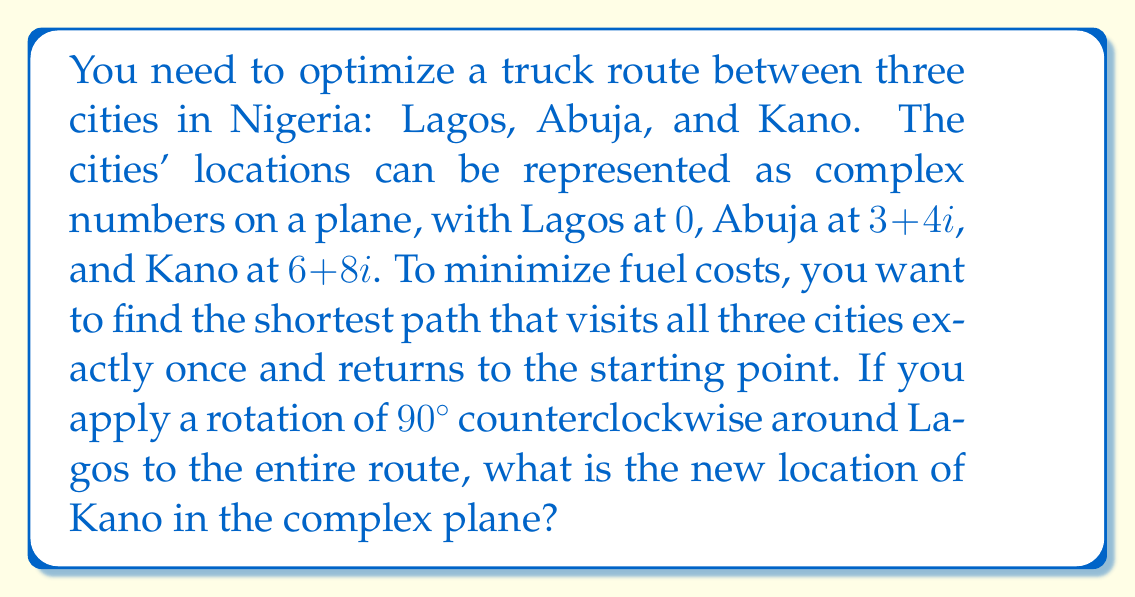Give your solution to this math problem. Let's approach this step-by-step:

1) First, we need to understand what a $90^\circ$ counterclockwise rotation means in terms of complex numbers. This rotation is equivalent to multiplying by $i$.

2) The original locations of the cities are:
   Lagos: $0$
   Abuja: $3+4i$
   Kano: $6+8i$

3) To rotate the entire route, we multiply each point by $i$:

   Lagos: $0 \cdot i = 0$
   Abuja: $(3+4i) \cdot i = 3i - 4 = -4 + 3i$
   Kano: $(6+8i) \cdot i = 6i - 8 = -8 + 6i$

4) Therefore, after the rotation, Kano's new location is $-8 + 6i$.

5) We can verify this geometrically:
   - The original point $(6,8)$ is at a distance of $\sqrt{6^2 + 8^2} = 10$ from the origin.
   - The new point $(-8,6)$ is also at a distance of $\sqrt{(-8)^2 + 6^2} = 10$ from the origin.
   - The angle has changed by exactly $90^\circ$.
Answer: $-8 + 6i$ 